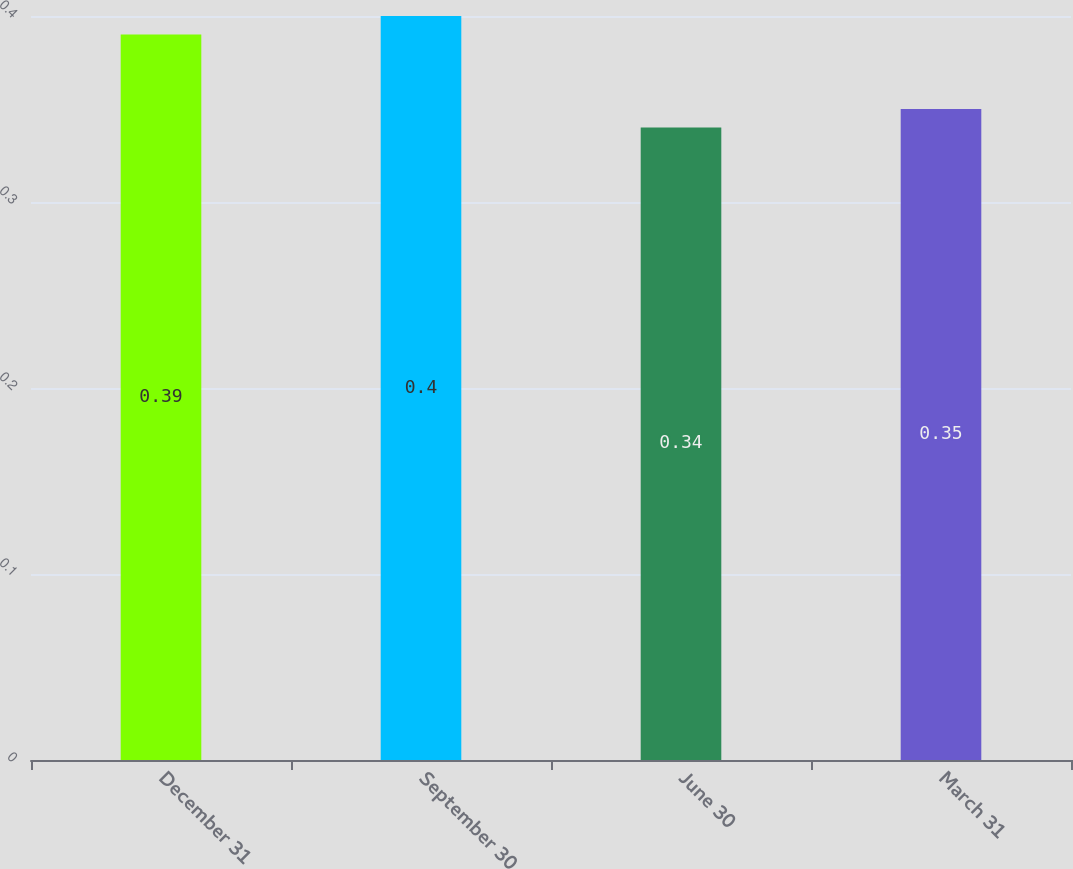Convert chart. <chart><loc_0><loc_0><loc_500><loc_500><bar_chart><fcel>December 31<fcel>September 30<fcel>June 30<fcel>March 31<nl><fcel>0.39<fcel>0.4<fcel>0.34<fcel>0.35<nl></chart> 